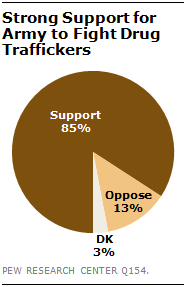List a handful of essential elements in this visual. According to the survey, 13% of respondents are against the army fighting drug traffickers. The result of deducting the median segment from the largest segment is 72. 